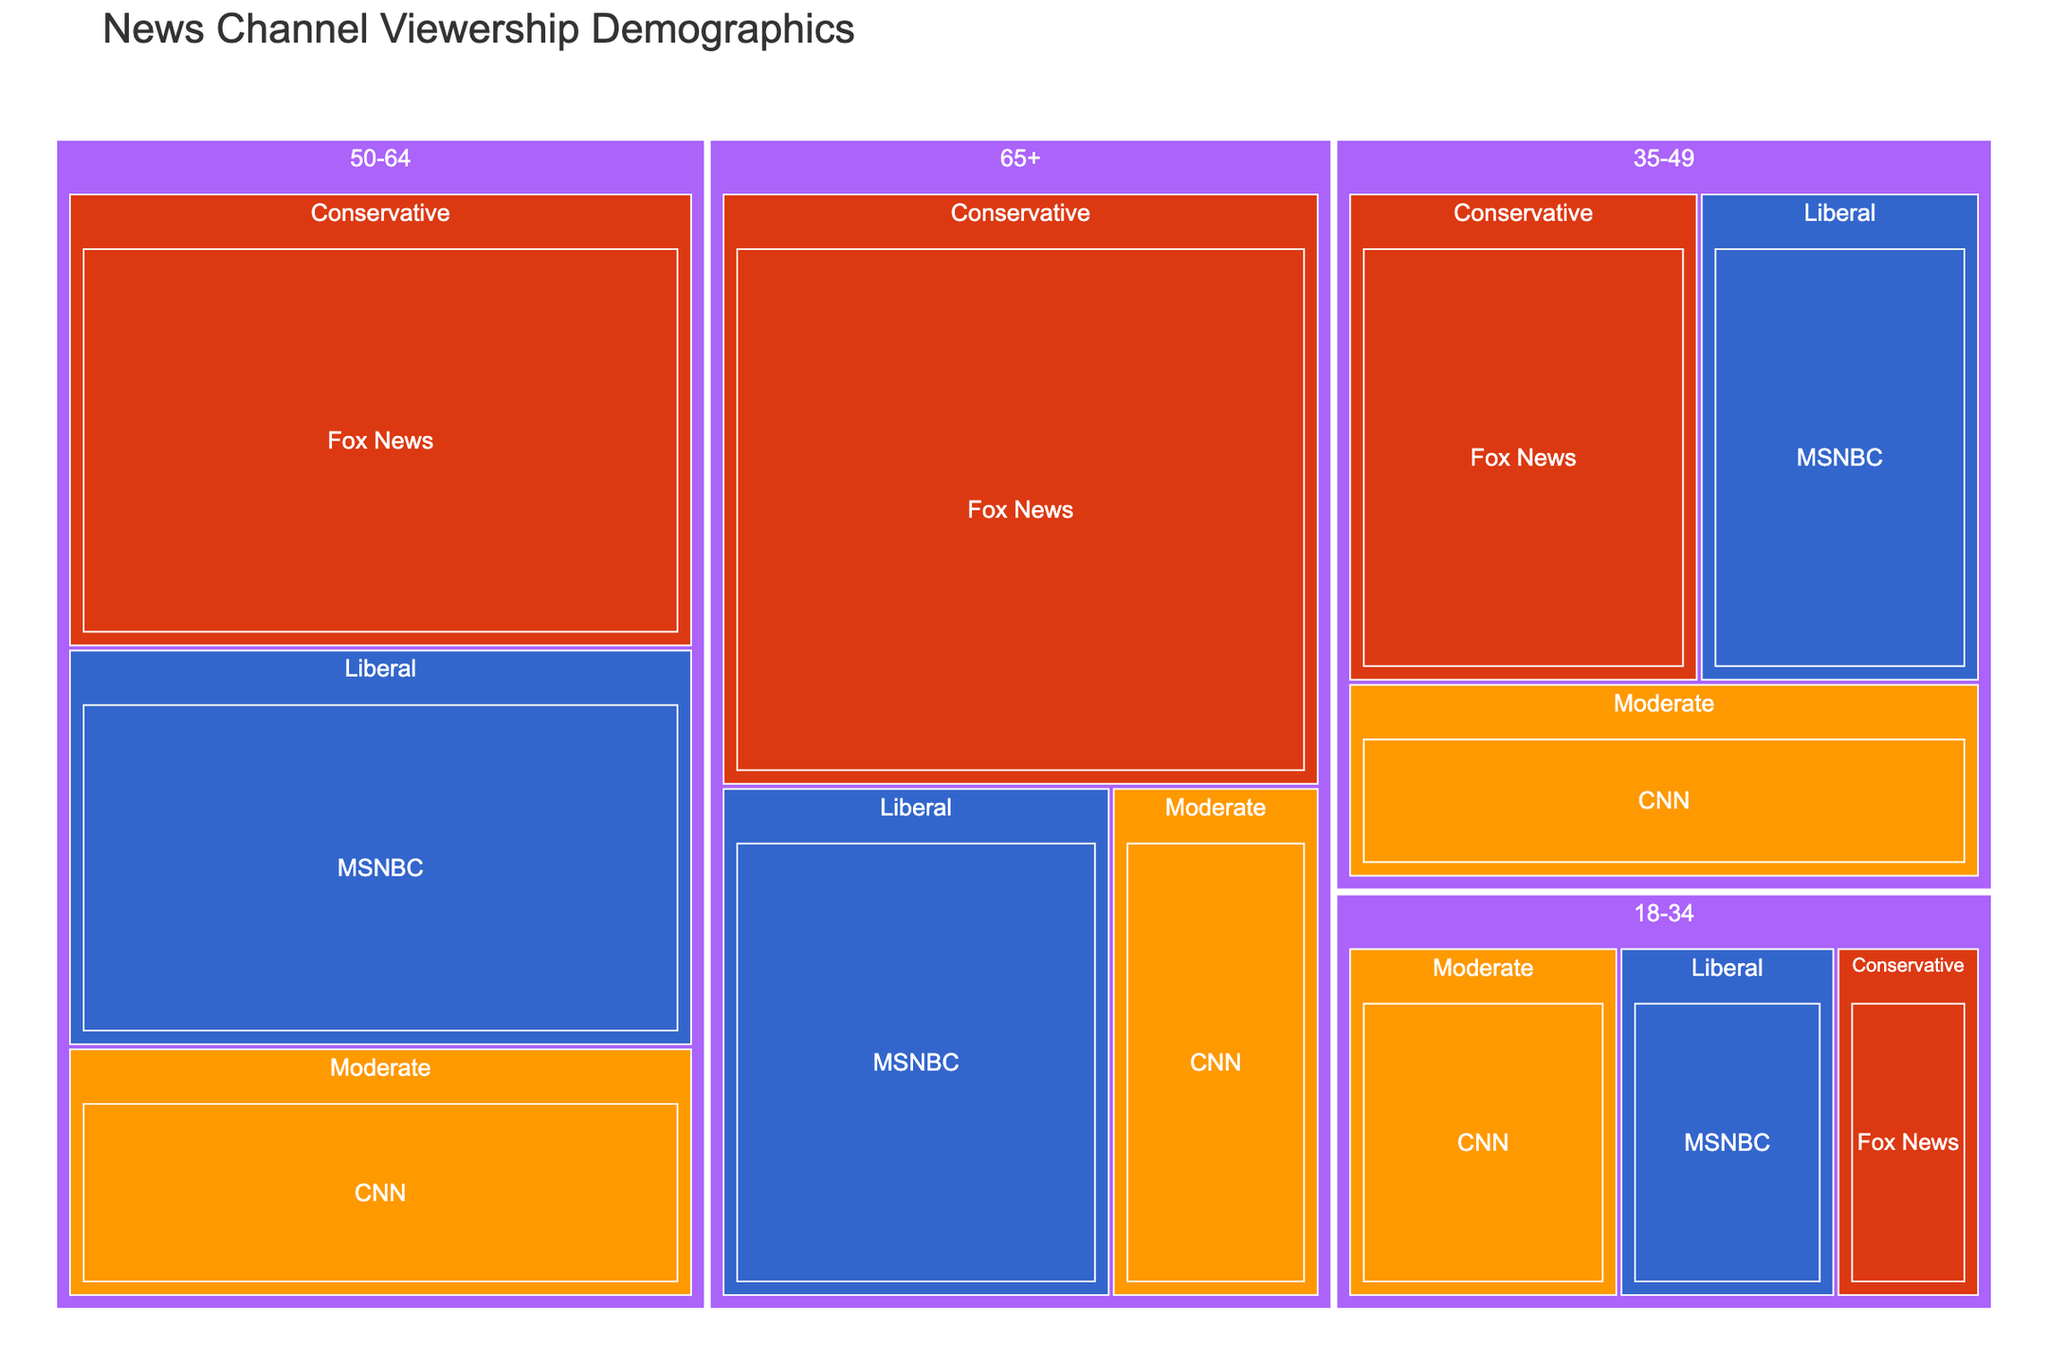What is the title of the treemap? The title is located at the top of the treemap. It reads "News Channel Viewership Demographics."
Answer: News Channel Viewership Demographics Which news network has the highest viewership in the age group 65+? To find the highest viewership in the 65+ age group, look for the largest section under 65+. Fox News has the largest viewership in this group.
Answer: Fox News How many viewership millions does Fox News have in the 50-64 age group? Find the Fox News section under the 50-64 age group. The viewership value is given in millions. It shows 4 million.
Answer: 4 million What is the most-watched network among 18-34-year-olds? Look at all the networks under the age group 18-34 and compare their sizes. CNN has the largest section.
Answer: CNN What is the combined viewership of MSNBC for the 35-49 and 50-64 age groups? Sum the viewership of MSNBC from both 35-49 (2 million) and 50-64 (3.5 million) age groups. 2 million + 3.5 million = 5.5 million.
Answer: 5.5 million How does the viewership of CNN in the 18-34 age group compare to its viewership in the 65+ age group? Compare the sizes of CNN sections in both the 18-34 and 65+ age groups. CNN has 1.5 million viewers in the 18-34 age group and 1.5 million viewers in the 65+ age group. They are the same.
Answer: Equal Which political affiliation has the highest total viewership across all age groups for MSNBC? Sum the viewership for each political affiliation for MSNBC across all age groups and compare. Liberals have 1.2 million (18-34) + 2 million (35-49) + 3.5 million (50-64) + 2.8 million (65+), which is the highest.
Answer: Liberal What's the difference in viewership of Fox News between the 35-49 and 50-64 age groups? Subtract the viewership of Fox News in the 35-49 age group (2.5 million) from that in the 50-64 age group (4 million). 4 million - 2.5 million = 1.5 million.
Answer: 1.5 million Which age group has the highest total viewership for CNN? Add the viewership for CNN across different political affiliations within each age group and compare. The 50-64 age group has the highest with 2.2 million.
Answer: 50-64 